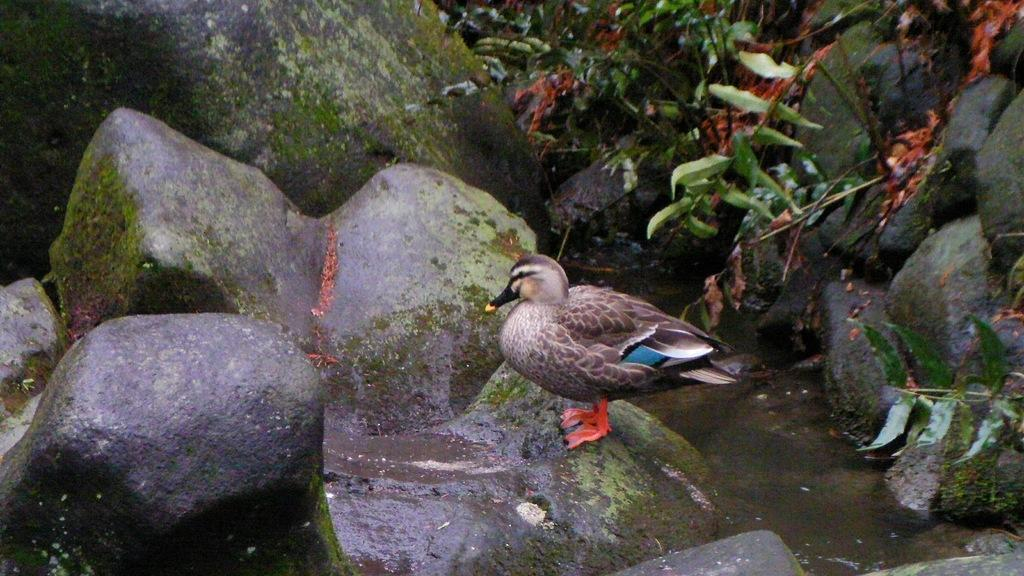What is the bird in the image sitting on? The bird is sitting on a stone in the image. What can be seen in the background of the image? There are rocks, plants, and water visible in the background of the image. Can you describe the time of day when the image was likely taken? The image was likely taken during the day, as there is sufficient light to see the details clearly. What type of honey is the bird using to build its nest in the image? There is no nest or honey present in the image; it features a bird sitting on a stone. What season is depicted in the image? The provided facts do not specify a season, so it cannot be determined from the image. 